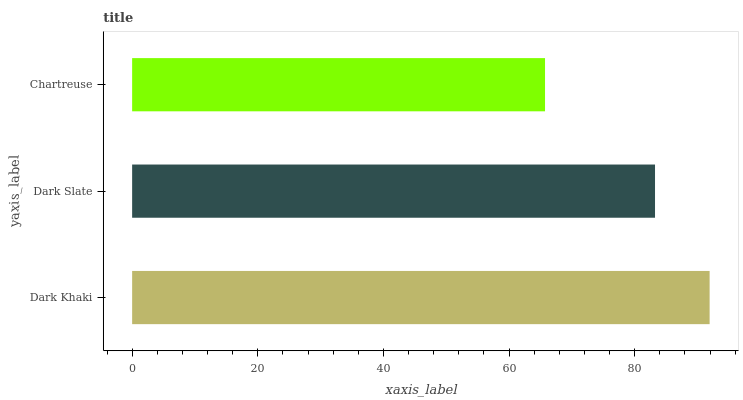Is Chartreuse the minimum?
Answer yes or no. Yes. Is Dark Khaki the maximum?
Answer yes or no. Yes. Is Dark Slate the minimum?
Answer yes or no. No. Is Dark Slate the maximum?
Answer yes or no. No. Is Dark Khaki greater than Dark Slate?
Answer yes or no. Yes. Is Dark Slate less than Dark Khaki?
Answer yes or no. Yes. Is Dark Slate greater than Dark Khaki?
Answer yes or no. No. Is Dark Khaki less than Dark Slate?
Answer yes or no. No. Is Dark Slate the high median?
Answer yes or no. Yes. Is Dark Slate the low median?
Answer yes or no. Yes. Is Dark Khaki the high median?
Answer yes or no. No. Is Chartreuse the low median?
Answer yes or no. No. 